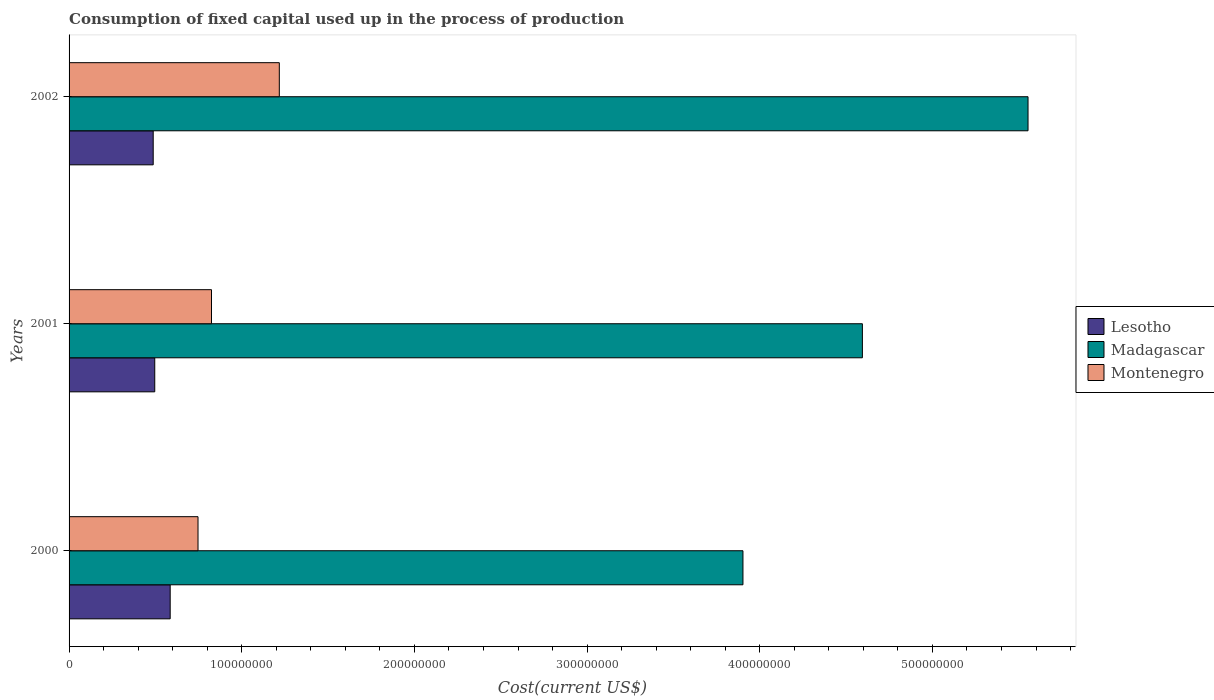How many groups of bars are there?
Make the answer very short. 3. Are the number of bars on each tick of the Y-axis equal?
Keep it short and to the point. Yes. What is the amount consumed in the process of production in Madagascar in 2002?
Ensure brevity in your answer.  5.55e+08. Across all years, what is the maximum amount consumed in the process of production in Madagascar?
Your answer should be compact. 5.55e+08. Across all years, what is the minimum amount consumed in the process of production in Madagascar?
Your answer should be compact. 3.90e+08. What is the total amount consumed in the process of production in Lesotho in the graph?
Your answer should be very brief. 1.57e+08. What is the difference between the amount consumed in the process of production in Madagascar in 2001 and that in 2002?
Give a very brief answer. -9.59e+07. What is the difference between the amount consumed in the process of production in Montenegro in 2001 and the amount consumed in the process of production in Madagascar in 2002?
Offer a terse response. -4.73e+08. What is the average amount consumed in the process of production in Montenegro per year?
Offer a terse response. 9.30e+07. In the year 2002, what is the difference between the amount consumed in the process of production in Montenegro and amount consumed in the process of production in Lesotho?
Provide a short and direct response. 7.30e+07. What is the ratio of the amount consumed in the process of production in Madagascar in 2000 to that in 2001?
Offer a terse response. 0.85. What is the difference between the highest and the second highest amount consumed in the process of production in Montenegro?
Make the answer very short. 3.93e+07. What is the difference between the highest and the lowest amount consumed in the process of production in Montenegro?
Provide a short and direct response. 4.71e+07. In how many years, is the amount consumed in the process of production in Madagascar greater than the average amount consumed in the process of production in Madagascar taken over all years?
Keep it short and to the point. 1. What does the 2nd bar from the top in 2002 represents?
Offer a very short reply. Madagascar. What does the 2nd bar from the bottom in 2001 represents?
Provide a succinct answer. Madagascar. How many years are there in the graph?
Your response must be concise. 3. What is the difference between two consecutive major ticks on the X-axis?
Give a very brief answer. 1.00e+08. Does the graph contain any zero values?
Ensure brevity in your answer.  No. Does the graph contain grids?
Give a very brief answer. No. What is the title of the graph?
Give a very brief answer. Consumption of fixed capital used up in the process of production. Does "Azerbaijan" appear as one of the legend labels in the graph?
Provide a short and direct response. No. What is the label or title of the X-axis?
Ensure brevity in your answer.  Cost(current US$). What is the Cost(current US$) in Lesotho in 2000?
Give a very brief answer. 5.86e+07. What is the Cost(current US$) in Madagascar in 2000?
Your answer should be compact. 3.90e+08. What is the Cost(current US$) of Montenegro in 2000?
Make the answer very short. 7.47e+07. What is the Cost(current US$) of Lesotho in 2001?
Your answer should be very brief. 4.96e+07. What is the Cost(current US$) in Madagascar in 2001?
Give a very brief answer. 4.59e+08. What is the Cost(current US$) in Montenegro in 2001?
Your answer should be very brief. 8.25e+07. What is the Cost(current US$) in Lesotho in 2002?
Your answer should be compact. 4.87e+07. What is the Cost(current US$) in Madagascar in 2002?
Keep it short and to the point. 5.55e+08. What is the Cost(current US$) in Montenegro in 2002?
Keep it short and to the point. 1.22e+08. Across all years, what is the maximum Cost(current US$) of Lesotho?
Ensure brevity in your answer.  5.86e+07. Across all years, what is the maximum Cost(current US$) in Madagascar?
Make the answer very short. 5.55e+08. Across all years, what is the maximum Cost(current US$) in Montenegro?
Offer a very short reply. 1.22e+08. Across all years, what is the minimum Cost(current US$) of Lesotho?
Keep it short and to the point. 4.87e+07. Across all years, what is the minimum Cost(current US$) in Madagascar?
Keep it short and to the point. 3.90e+08. Across all years, what is the minimum Cost(current US$) in Montenegro?
Make the answer very short. 7.47e+07. What is the total Cost(current US$) of Lesotho in the graph?
Provide a short and direct response. 1.57e+08. What is the total Cost(current US$) of Madagascar in the graph?
Offer a very short reply. 1.41e+09. What is the total Cost(current US$) of Montenegro in the graph?
Provide a succinct answer. 2.79e+08. What is the difference between the Cost(current US$) in Lesotho in 2000 and that in 2001?
Your response must be concise. 8.94e+06. What is the difference between the Cost(current US$) of Madagascar in 2000 and that in 2001?
Provide a succinct answer. -6.92e+07. What is the difference between the Cost(current US$) in Montenegro in 2000 and that in 2001?
Offer a terse response. -7.81e+06. What is the difference between the Cost(current US$) of Lesotho in 2000 and that in 2002?
Provide a succinct answer. 9.83e+06. What is the difference between the Cost(current US$) in Madagascar in 2000 and that in 2002?
Offer a terse response. -1.65e+08. What is the difference between the Cost(current US$) in Montenegro in 2000 and that in 2002?
Give a very brief answer. -4.71e+07. What is the difference between the Cost(current US$) of Lesotho in 2001 and that in 2002?
Keep it short and to the point. 8.89e+05. What is the difference between the Cost(current US$) of Madagascar in 2001 and that in 2002?
Provide a succinct answer. -9.59e+07. What is the difference between the Cost(current US$) of Montenegro in 2001 and that in 2002?
Ensure brevity in your answer.  -3.93e+07. What is the difference between the Cost(current US$) of Lesotho in 2000 and the Cost(current US$) of Madagascar in 2001?
Provide a short and direct response. -4.01e+08. What is the difference between the Cost(current US$) in Lesotho in 2000 and the Cost(current US$) in Montenegro in 2001?
Offer a very short reply. -2.39e+07. What is the difference between the Cost(current US$) in Madagascar in 2000 and the Cost(current US$) in Montenegro in 2001?
Offer a very short reply. 3.08e+08. What is the difference between the Cost(current US$) of Lesotho in 2000 and the Cost(current US$) of Madagascar in 2002?
Provide a short and direct response. -4.97e+08. What is the difference between the Cost(current US$) in Lesotho in 2000 and the Cost(current US$) in Montenegro in 2002?
Offer a very short reply. -6.32e+07. What is the difference between the Cost(current US$) of Madagascar in 2000 and the Cost(current US$) of Montenegro in 2002?
Offer a very short reply. 2.69e+08. What is the difference between the Cost(current US$) in Lesotho in 2001 and the Cost(current US$) in Madagascar in 2002?
Your answer should be compact. -5.06e+08. What is the difference between the Cost(current US$) in Lesotho in 2001 and the Cost(current US$) in Montenegro in 2002?
Give a very brief answer. -7.21e+07. What is the difference between the Cost(current US$) of Madagascar in 2001 and the Cost(current US$) of Montenegro in 2002?
Offer a terse response. 3.38e+08. What is the average Cost(current US$) of Lesotho per year?
Give a very brief answer. 5.23e+07. What is the average Cost(current US$) of Madagascar per year?
Offer a very short reply. 4.68e+08. What is the average Cost(current US$) of Montenegro per year?
Provide a succinct answer. 9.30e+07. In the year 2000, what is the difference between the Cost(current US$) in Lesotho and Cost(current US$) in Madagascar?
Make the answer very short. -3.32e+08. In the year 2000, what is the difference between the Cost(current US$) in Lesotho and Cost(current US$) in Montenegro?
Your response must be concise. -1.61e+07. In the year 2000, what is the difference between the Cost(current US$) of Madagascar and Cost(current US$) of Montenegro?
Your answer should be very brief. 3.16e+08. In the year 2001, what is the difference between the Cost(current US$) in Lesotho and Cost(current US$) in Madagascar?
Make the answer very short. -4.10e+08. In the year 2001, what is the difference between the Cost(current US$) in Lesotho and Cost(current US$) in Montenegro?
Provide a short and direct response. -3.29e+07. In the year 2001, what is the difference between the Cost(current US$) of Madagascar and Cost(current US$) of Montenegro?
Give a very brief answer. 3.77e+08. In the year 2002, what is the difference between the Cost(current US$) of Lesotho and Cost(current US$) of Madagascar?
Ensure brevity in your answer.  -5.07e+08. In the year 2002, what is the difference between the Cost(current US$) of Lesotho and Cost(current US$) of Montenegro?
Keep it short and to the point. -7.30e+07. In the year 2002, what is the difference between the Cost(current US$) of Madagascar and Cost(current US$) of Montenegro?
Your answer should be compact. 4.34e+08. What is the ratio of the Cost(current US$) of Lesotho in 2000 to that in 2001?
Provide a succinct answer. 1.18. What is the ratio of the Cost(current US$) in Madagascar in 2000 to that in 2001?
Your response must be concise. 0.85. What is the ratio of the Cost(current US$) of Montenegro in 2000 to that in 2001?
Offer a very short reply. 0.91. What is the ratio of the Cost(current US$) of Lesotho in 2000 to that in 2002?
Offer a terse response. 1.2. What is the ratio of the Cost(current US$) in Madagascar in 2000 to that in 2002?
Offer a very short reply. 0.7. What is the ratio of the Cost(current US$) in Montenegro in 2000 to that in 2002?
Provide a short and direct response. 0.61. What is the ratio of the Cost(current US$) in Lesotho in 2001 to that in 2002?
Your response must be concise. 1.02. What is the ratio of the Cost(current US$) in Madagascar in 2001 to that in 2002?
Your answer should be compact. 0.83. What is the ratio of the Cost(current US$) of Montenegro in 2001 to that in 2002?
Give a very brief answer. 0.68. What is the difference between the highest and the second highest Cost(current US$) of Lesotho?
Your answer should be compact. 8.94e+06. What is the difference between the highest and the second highest Cost(current US$) of Madagascar?
Ensure brevity in your answer.  9.59e+07. What is the difference between the highest and the second highest Cost(current US$) of Montenegro?
Your answer should be very brief. 3.93e+07. What is the difference between the highest and the lowest Cost(current US$) in Lesotho?
Offer a terse response. 9.83e+06. What is the difference between the highest and the lowest Cost(current US$) of Madagascar?
Provide a short and direct response. 1.65e+08. What is the difference between the highest and the lowest Cost(current US$) of Montenegro?
Your response must be concise. 4.71e+07. 